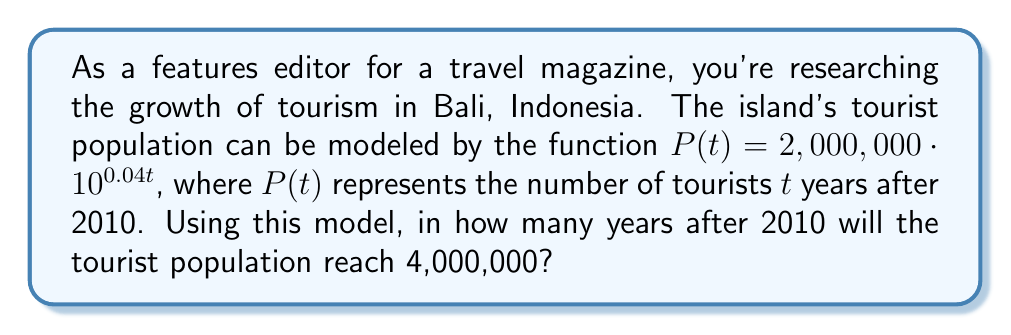Show me your answer to this math problem. To solve this problem, we need to use logarithms. Let's approach this step-by-step:

1) We're looking for the time $t$ when $P(t) = 4,000,000$. So we can set up the equation:

   $4,000,000 = 2,000,000 \cdot 10^{0.04t}$

2) First, let's divide both sides by 2,000,000:

   $2 = 10^{0.04t}$

3) Now, we can take the logarithm (base 10) of both sides:

   $\log_{10}(2) = \log_{10}(10^{0.04t})$

4) Using the logarithm property $\log_a(a^x) = x$, we can simplify the right side:

   $\log_{10}(2) = 0.04t$

5) Now we can solve for $t$ by dividing both sides by 0.04:

   $t = \frac{\log_{10}(2)}{0.04}$

6) Using a calculator or computer, we can evaluate this:

   $t \approx \frac{0.30103}{0.04} \approx 7.52575$

7) Since we're dealing with years, we should round up to the nearest whole year.
Answer: The tourist population will reach 4,000,000 in approximately 8 years after 2010, which would be in 2018. 